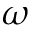<formula> <loc_0><loc_0><loc_500><loc_500>\omega</formula> 